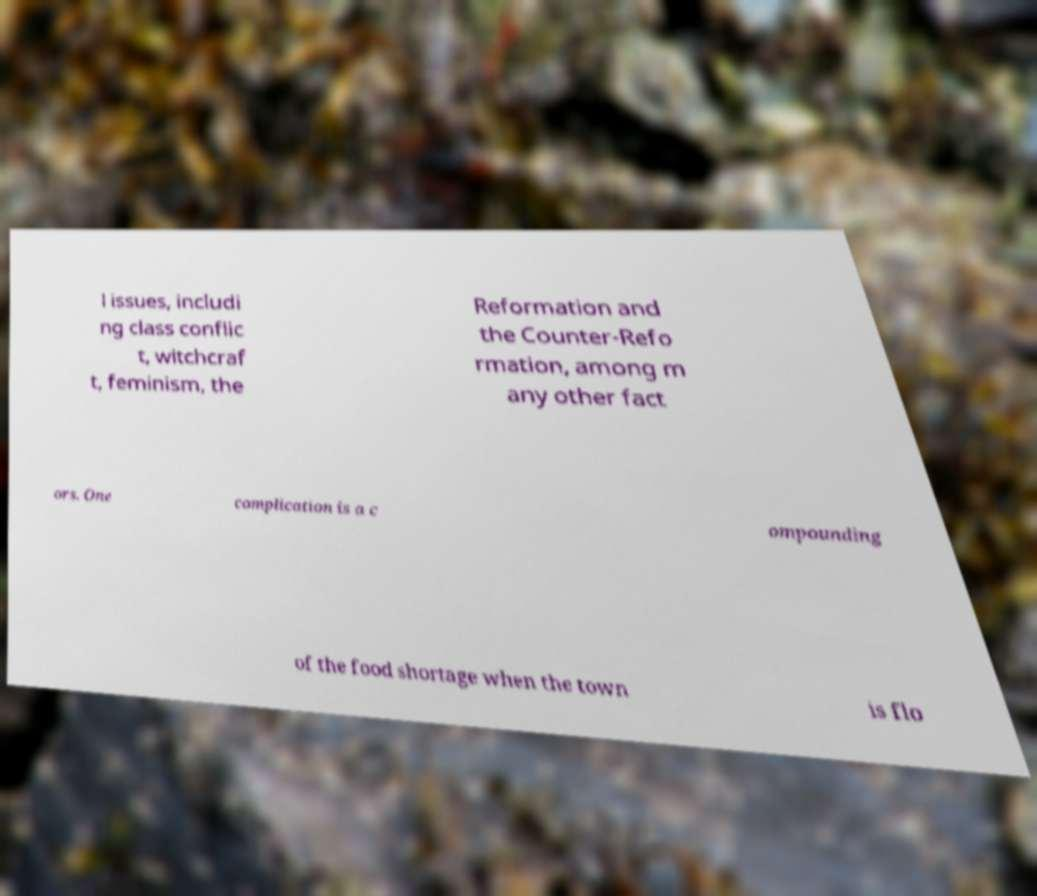I need the written content from this picture converted into text. Can you do that? l issues, includi ng class conflic t, witchcraf t, feminism, the Reformation and the Counter-Refo rmation, among m any other fact ors. One complication is a c ompounding of the food shortage when the town is flo 